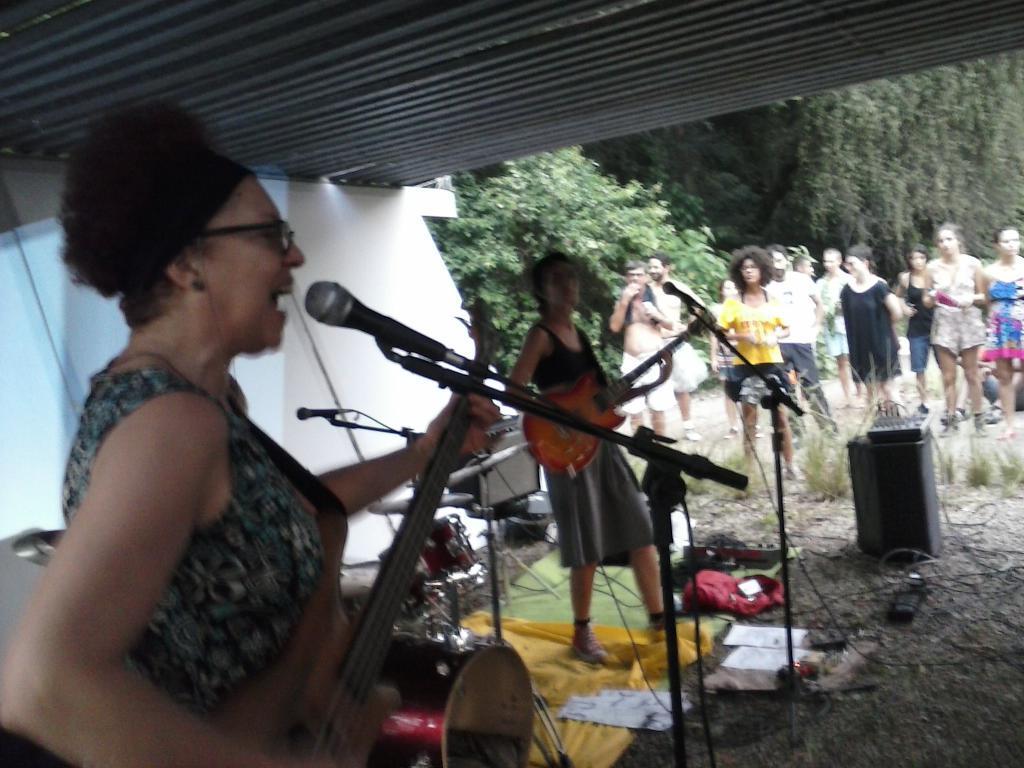How would you summarize this image in a sentence or two? In this picture we can see two women holding guitars with their hands and in front of them we can see my, devices, papers, clothes, cables on the ground and in the background we can see a group of people, grass, trees, roof, wall, some objects. 